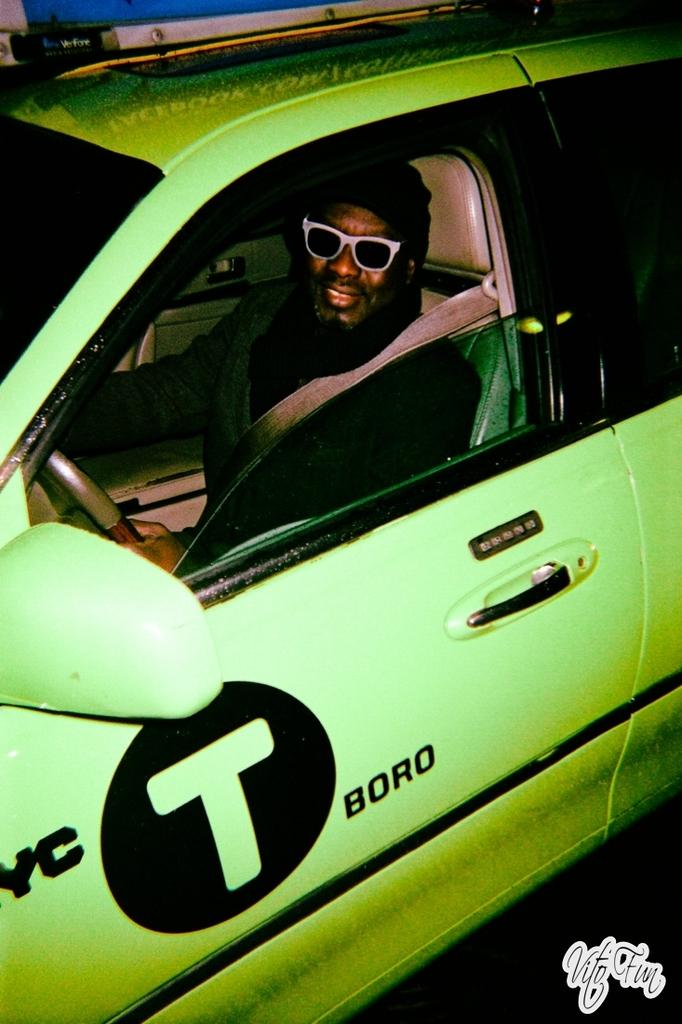What is the main subject of the picture? The main subject of the picture is a car. Can you describe the person inside the car? A man is inside the car, and he is wearing a seatbelt. What is the man doing in the car? The man is holding a steering wheel, which suggests he is driving the car. What is the color of the car? The car is green in color. Are there any unique features on the car? Yes, the car has some design on it. What time of day is recess taking place in the image? There is no mention of recess or any school-related activity in the image; it features a car with a man inside. What is the moon's position in the image? The image does not show the moon; it only features a car with a man inside. 